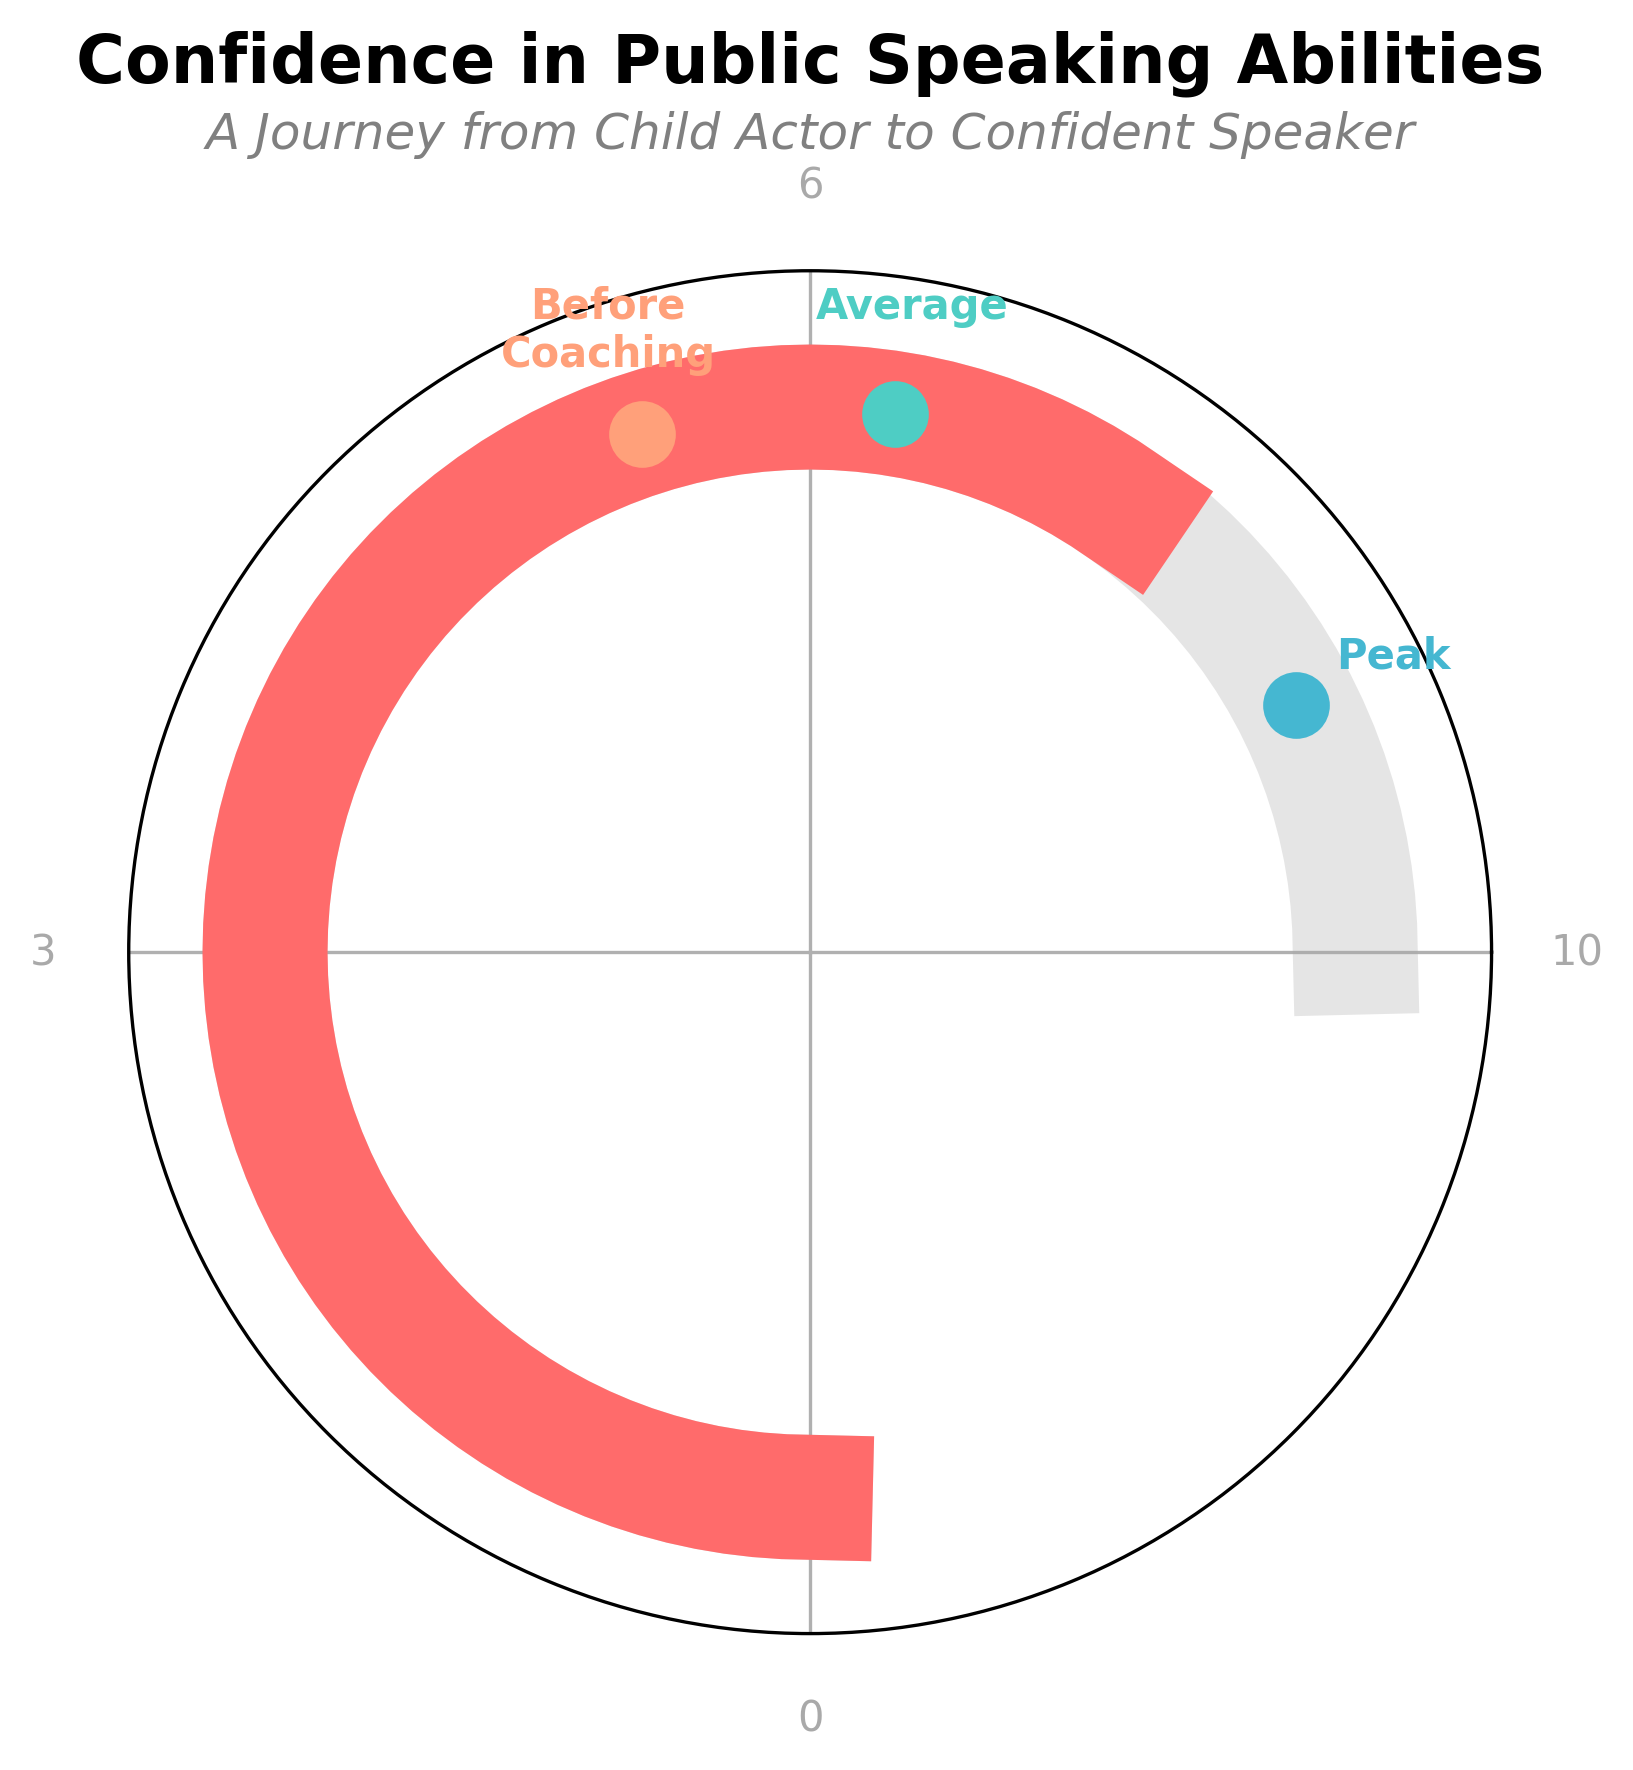What is the current confidence level in public speaking abilities? The current confidence level is marked with a red section on the gauge, indicated by a value text displayed at the bottom-center of the plot.
Answer: 8 What are the minimum and maximum values on the gauge? The minimum value is shown at the beginning of the gauge (left-most part) and the maximum value at the end of the gauge (right-most part). These are labeled with 0 and 10 respectively.
Answer: 0 and 10 How does the average confidence level for former child actors compare to your current confidence level? The average confidence level for former child actors is marked by a green dot with the label 'Average'. Comparing this with the red section marking the current level, the average (7) is less than the current confidence level (8).
Answer: Less than What's the difference between your peak confidence during your career and your confidence level before coaching? The peak confidence during your career is marked by a blue dot and labeled 'Peak' with a value of 9. The confidence level before coaching is marked by an orange dot and labeled 'Before Coaching' with a value of 6. The difference between these values is 9 - 6 = 3.
Answer: 3 What can be inferred about the impact of coaching on your confidence in public speaking? Before coaching, the confidence level was at 6, while the current confidence level is at 8. This suggests a positive impact of coaching, increasing the confidence by 2 points.
Answer: Increased by 2 points What color is used to represent the average confidence level for former child actors? The average confidence level is represented by a green dot on the gauge.
Answer: Green How much higher is your current confidence level compared to the average confidence level for former child actors? The current confidence level is 8, whereas the average confidence level for former child actors is 7. The difference between these two values is 8 - 7 = 1.
Answer: 1 What does the light grey arc on the outside of the gauge represent? The light grey arc marks the scale of the gauge, extending from the minimum value (0) to the maximum value (10).
Answer: The scale 